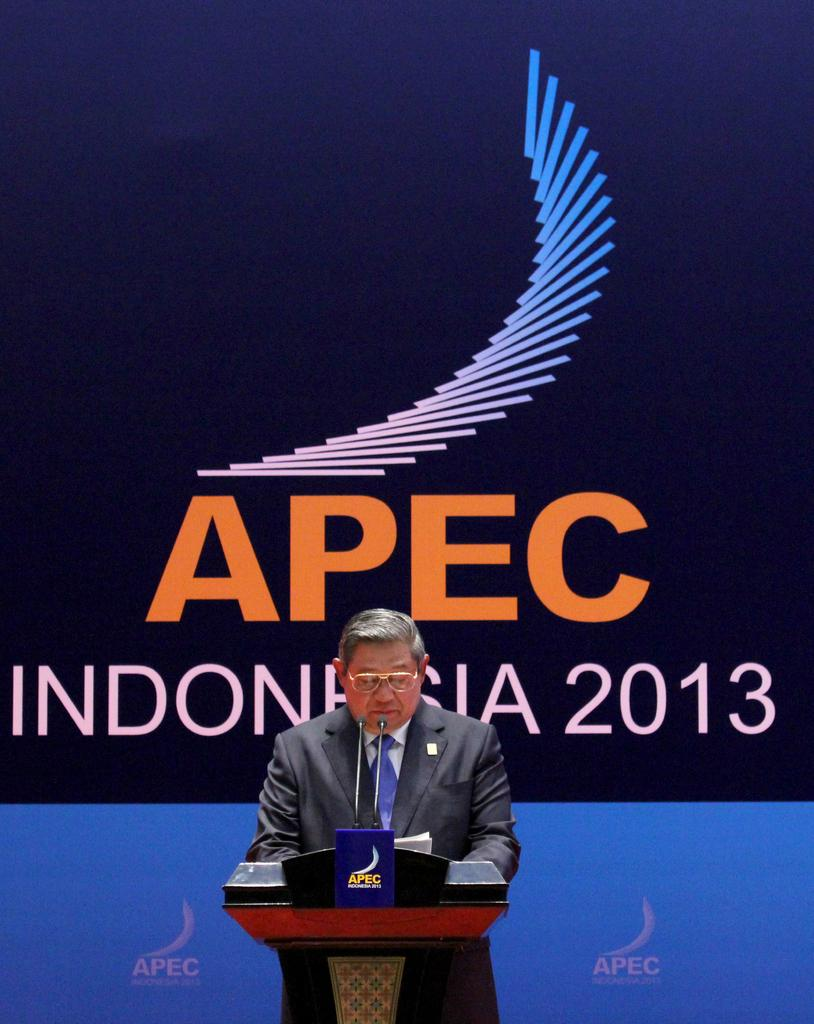<image>
Present a compact description of the photo's key features. A man is speaking at a podium at APEC Indonesia 2013. 